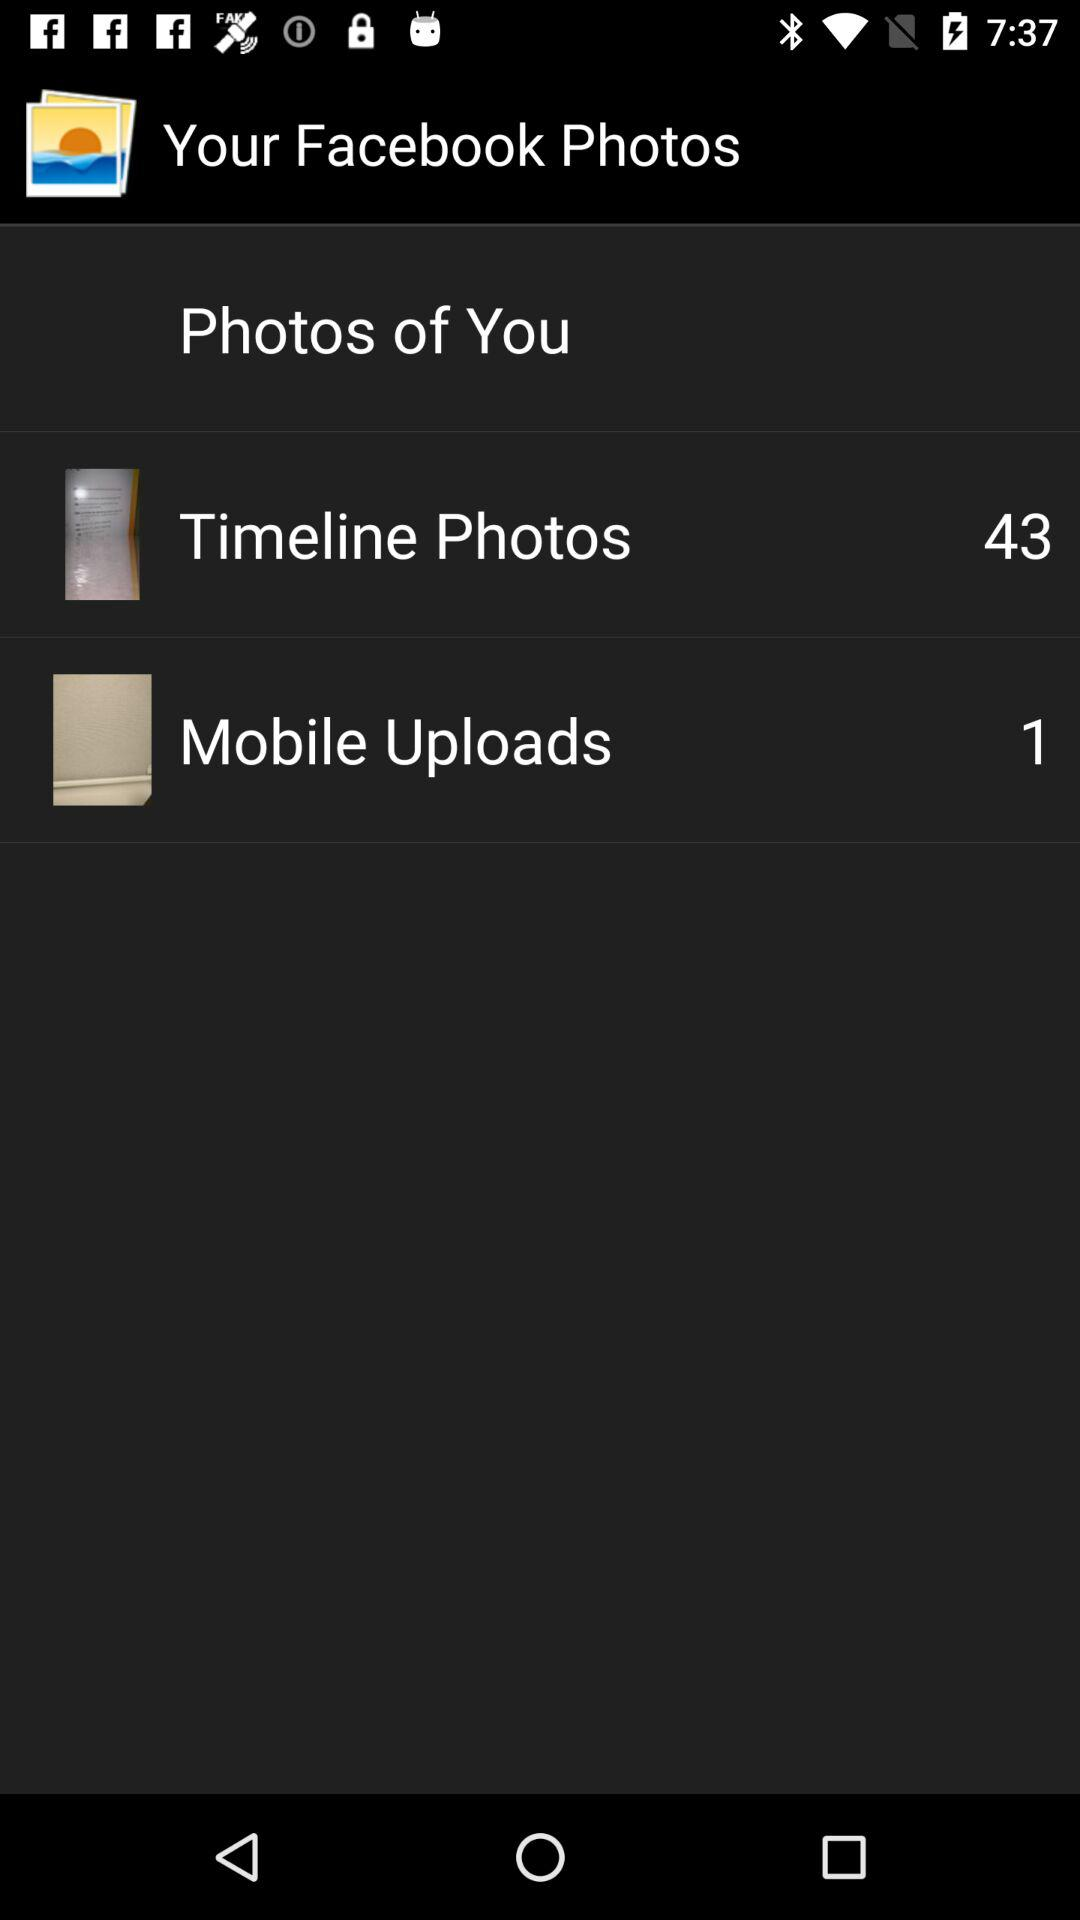How many "Timeline Photos" are there? There are 43 "Timeline Photos". 